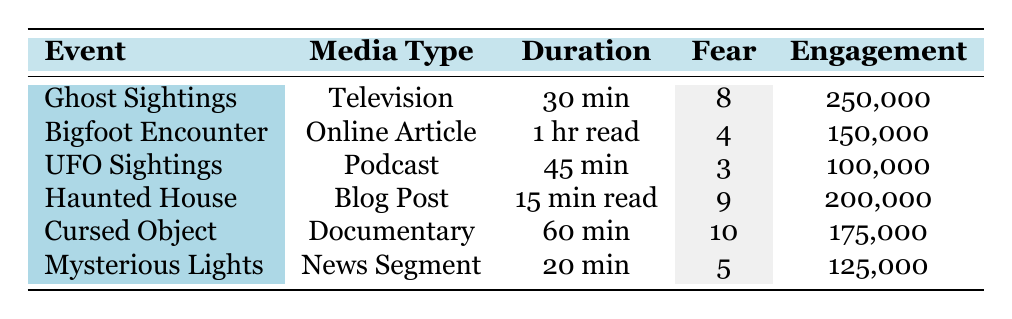What is the media type for the "Cursed Object: The Dybbuk Box" event? By looking at the table under the "Media Type" column for the corresponding event, it shows that the media type is "Documentary."
Answer: Documentary Which event has the highest level of fear reported? The fear levels for each event can be found in the "Fear" column. The highest value is 10, which corresponds to the "Cursed Object: The Dybbuk Box" event.
Answer: Cursed Object: The Dybbuk Box What is the average audience engagement across all events? To find the average, sum the engagement values (250,000 + 150,000 + 100,000 + 200,000 + 175,000 + 125,000 = 1,000,000) and divide by the number of events (6). The average is 1,000,000 / 6 = 166,667.
Answer: 166,667 Which event received the least amount of engagement? Reviewing the "Engagement" column, the event with the lowest value is "UFO Sightings Over Arizona," with an engagement of 100,000.
Answer: UFO Sightings Over Arizona Is there any event that has a curiosity score higher than 8? By checking the "Curiosity" scores, the events "UFO Sightings Over Arizona" (10) and "Haunted House Phenomena in New Orleans" (8) show that there are events that fulfill this condition, and therefore the answer is yes.
Answer: Yes What is the difference in engagement between the "Ghost Sightings in Gettysburg" and "Bigfoot Encounter in Washington State"? Looking at their engagement values, the "Ghost Sightings" event has 250,000 and the "Bigfoot Encounter" has 150,000. The difference is 250,000 - 150,000 = 100,000.
Answer: 100,000 How many events had a fear score of 5 or lower? The fear scores show that "Bigfoot Encounter in Washington State" (4), "UFO Sightings Over Arizona" (3), and "Mysterious Lights Over Phoenix" (5) have all had scores of 5 or lower. Thus, there are 3 events fitting this criterion.
Answer: 3 Which event has the highest curiosity score, and what was the audience engagement for that event? The maximum curiosity score is 10, which is for "UFO Sightings Over Arizona." The engagement for this event is 100,000.
Answer: UFO Sightings Over Arizona, 100,000 Is the fear level proportional to audience engagement for the "Haunted House Phenomena in New Orleans"? The fear level is 9, and the engagement is 200,000. While it seems high, we need to compare it to other events for a clear understanding. There isn't sufficient data to establish a proportional relationship definitively.
Answer: No What is the most common media type among the listed events? The media types are varied (Television, Online Article, Podcast, Blog Post, Documentary, News Segment). Each type appears only once, making no type predominant.
Answer: None 